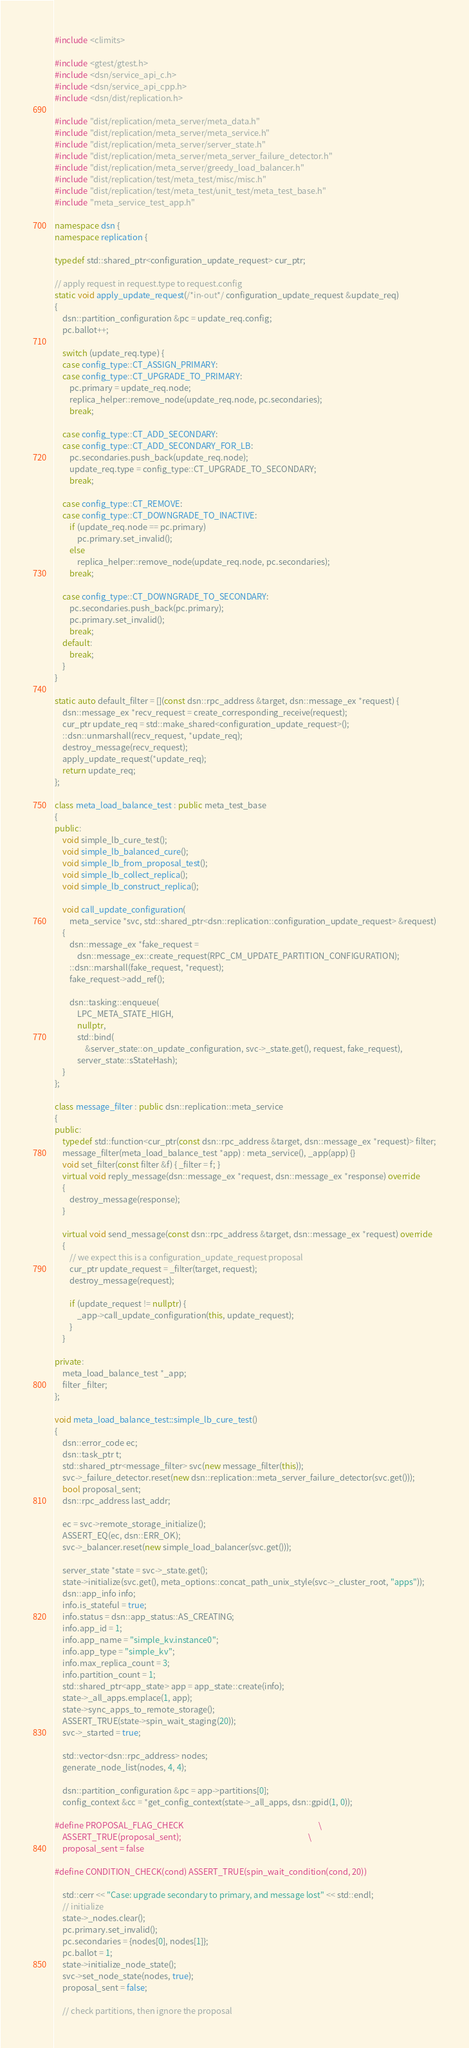<code> <loc_0><loc_0><loc_500><loc_500><_C++_>#include <climits>

#include <gtest/gtest.h>
#include <dsn/service_api_c.h>
#include <dsn/service_api_cpp.h>
#include <dsn/dist/replication.h>

#include "dist/replication/meta_server/meta_data.h"
#include "dist/replication/meta_server/meta_service.h"
#include "dist/replication/meta_server/server_state.h"
#include "dist/replication/meta_server/meta_server_failure_detector.h"
#include "dist/replication/meta_server/greedy_load_balancer.h"
#include "dist/replication/test/meta_test/misc/misc.h"
#include "dist/replication/test/meta_test/unit_test/meta_test_base.h"
#include "meta_service_test_app.h"

namespace dsn {
namespace replication {

typedef std::shared_ptr<configuration_update_request> cur_ptr;

// apply request in request.type to request.config
static void apply_update_request(/*in-out*/ configuration_update_request &update_req)
{
    dsn::partition_configuration &pc = update_req.config;
    pc.ballot++;

    switch (update_req.type) {
    case config_type::CT_ASSIGN_PRIMARY:
    case config_type::CT_UPGRADE_TO_PRIMARY:
        pc.primary = update_req.node;
        replica_helper::remove_node(update_req.node, pc.secondaries);
        break;

    case config_type::CT_ADD_SECONDARY:
    case config_type::CT_ADD_SECONDARY_FOR_LB:
        pc.secondaries.push_back(update_req.node);
        update_req.type = config_type::CT_UPGRADE_TO_SECONDARY;
        break;

    case config_type::CT_REMOVE:
    case config_type::CT_DOWNGRADE_TO_INACTIVE:
        if (update_req.node == pc.primary)
            pc.primary.set_invalid();
        else
            replica_helper::remove_node(update_req.node, pc.secondaries);
        break;

    case config_type::CT_DOWNGRADE_TO_SECONDARY:
        pc.secondaries.push_back(pc.primary);
        pc.primary.set_invalid();
        break;
    default:
        break;
    }
}

static auto default_filter = [](const dsn::rpc_address &target, dsn::message_ex *request) {
    dsn::message_ex *recv_request = create_corresponding_receive(request);
    cur_ptr update_req = std::make_shared<configuration_update_request>();
    ::dsn::unmarshall(recv_request, *update_req);
    destroy_message(recv_request);
    apply_update_request(*update_req);
    return update_req;
};

class meta_load_balance_test : public meta_test_base
{
public:
    void simple_lb_cure_test();
    void simple_lb_balanced_cure();
    void simple_lb_from_proposal_test();
    void simple_lb_collect_replica();
    void simple_lb_construct_replica();

    void call_update_configuration(
        meta_service *svc, std::shared_ptr<dsn::replication::configuration_update_request> &request)
    {
        dsn::message_ex *fake_request =
            dsn::message_ex::create_request(RPC_CM_UPDATE_PARTITION_CONFIGURATION);
        ::dsn::marshall(fake_request, *request);
        fake_request->add_ref();

        dsn::tasking::enqueue(
            LPC_META_STATE_HIGH,
            nullptr,
            std::bind(
                &server_state::on_update_configuration, svc->_state.get(), request, fake_request),
            server_state::sStateHash);
    }
};

class message_filter : public dsn::replication::meta_service
{
public:
    typedef std::function<cur_ptr(const dsn::rpc_address &target, dsn::message_ex *request)> filter;
    message_filter(meta_load_balance_test *app) : meta_service(), _app(app) {}
    void set_filter(const filter &f) { _filter = f; }
    virtual void reply_message(dsn::message_ex *request, dsn::message_ex *response) override
    {
        destroy_message(response);
    }

    virtual void send_message(const dsn::rpc_address &target, dsn::message_ex *request) override
    {
        // we expect this is a configuration_update_request proposal
        cur_ptr update_request = _filter(target, request);
        destroy_message(request);

        if (update_request != nullptr) {
            _app->call_update_configuration(this, update_request);
        }
    }

private:
    meta_load_balance_test *_app;
    filter _filter;
};

void meta_load_balance_test::simple_lb_cure_test()
{
    dsn::error_code ec;
    dsn::task_ptr t;
    std::shared_ptr<message_filter> svc(new message_filter(this));
    svc->_failure_detector.reset(new dsn::replication::meta_server_failure_detector(svc.get()));
    bool proposal_sent;
    dsn::rpc_address last_addr;

    ec = svc->remote_storage_initialize();
    ASSERT_EQ(ec, dsn::ERR_OK);
    svc->_balancer.reset(new simple_load_balancer(svc.get()));

    server_state *state = svc->_state.get();
    state->initialize(svc.get(), meta_options::concat_path_unix_style(svc->_cluster_root, "apps"));
    dsn::app_info info;
    info.is_stateful = true;
    info.status = dsn::app_status::AS_CREATING;
    info.app_id = 1;
    info.app_name = "simple_kv.instance0";
    info.app_type = "simple_kv";
    info.max_replica_count = 3;
    info.partition_count = 1;
    std::shared_ptr<app_state> app = app_state::create(info);
    state->_all_apps.emplace(1, app);
    state->sync_apps_to_remote_storage();
    ASSERT_TRUE(state->spin_wait_staging(20));
    svc->_started = true;

    std::vector<dsn::rpc_address> nodes;
    generate_node_list(nodes, 4, 4);

    dsn::partition_configuration &pc = app->partitions[0];
    config_context &cc = *get_config_context(state->_all_apps, dsn::gpid(1, 0));

#define PROPOSAL_FLAG_CHECK                                                                        \
    ASSERT_TRUE(proposal_sent);                                                                    \
    proposal_sent = false

#define CONDITION_CHECK(cond) ASSERT_TRUE(spin_wait_condition(cond, 20))

    std::cerr << "Case: upgrade secondary to primary, and message lost" << std::endl;
    // initialize
    state->_nodes.clear();
    pc.primary.set_invalid();
    pc.secondaries = {nodes[0], nodes[1]};
    pc.ballot = 1;
    state->initialize_node_state();
    svc->set_node_state(nodes, true);
    proposal_sent = false;

    // check partitions, then ignore the proposal</code> 